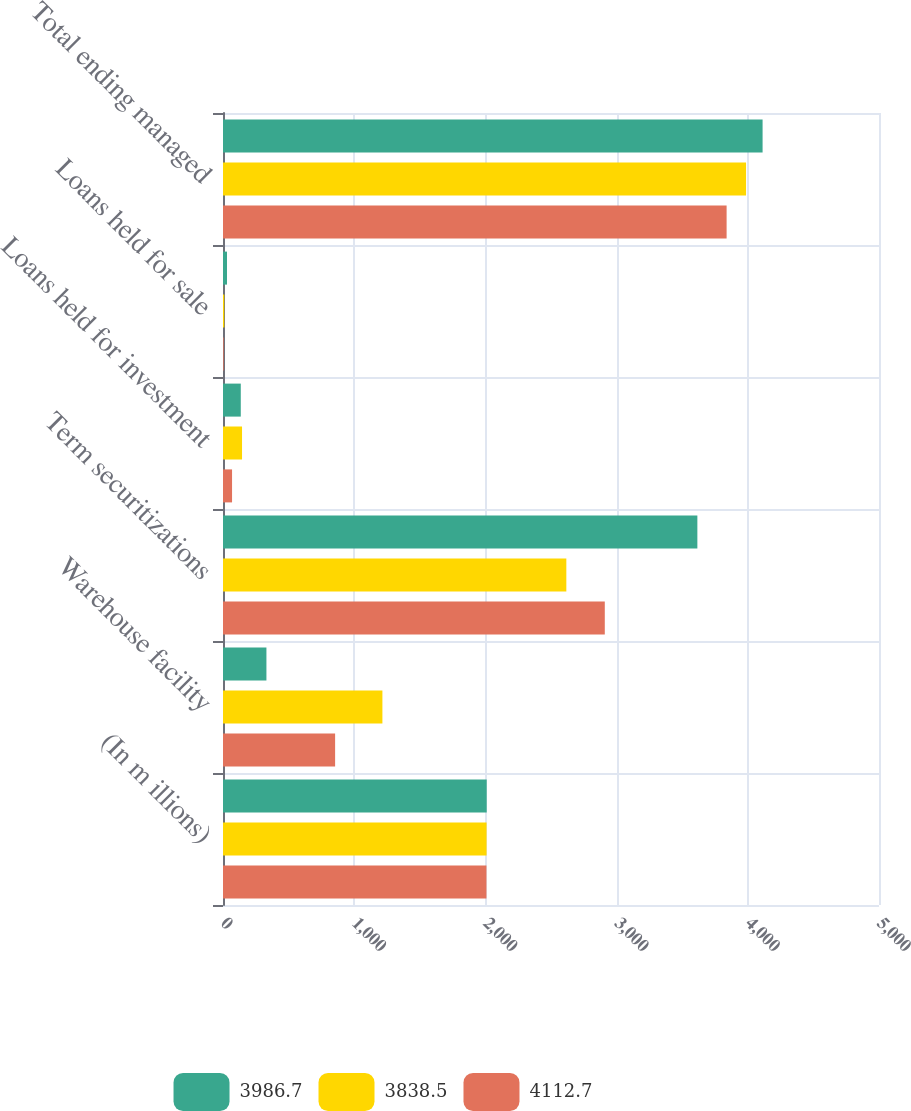Convert chart. <chart><loc_0><loc_0><loc_500><loc_500><stacked_bar_chart><ecel><fcel>(In m illions)<fcel>Warehouse facility<fcel>Term securitizations<fcel>Loans held for investment<fcel>Loans held for sale<fcel>Total ending managed<nl><fcel>3986.7<fcel>2010<fcel>331<fcel>3615.6<fcel>135.5<fcel>30.6<fcel>4112.7<nl><fcel>3838.5<fcel>2009<fcel>1215<fcel>2616.9<fcel>145.1<fcel>9.7<fcel>3986.7<nl><fcel>4112.7<fcel>2008<fcel>854.5<fcel>2910<fcel>69<fcel>5<fcel>3838.5<nl></chart> 